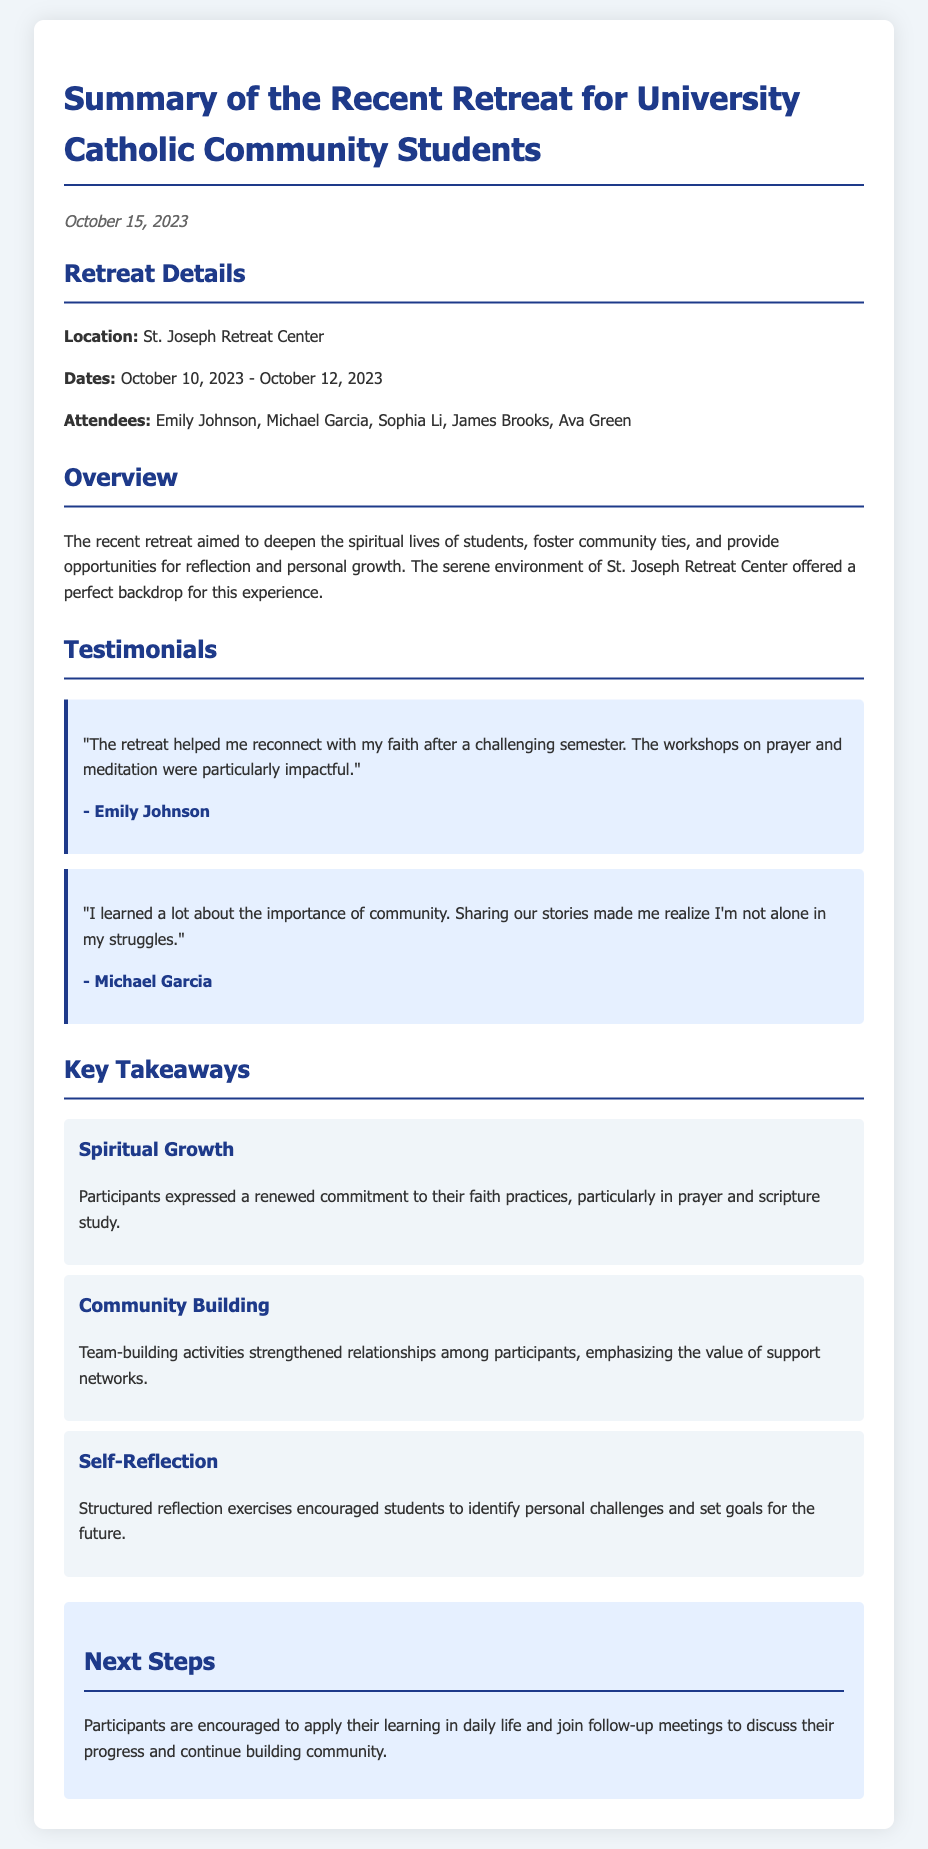What were the retreat dates? The retreat dates are indicated in the document under "Dates" in the "Retreat Details" section.
Answer: October 10, 2023 - October 12, 2023 Who was one of the attendees? The attendees' names are listed in the "Retreat Details" section, and one of them can be used as an answer.
Answer: Emily Johnson What is a key takeaway related to spiritual practices? The key takeaways are mentioned in the "Key Takeaways" section, specifically regarding spiritual growth and practices.
Answer: Spiritual Growth What type of activities emphasized community building? The "Key Takeaways" section refers to types of activities that strengthened relationships, leading to community building.
Answer: Team-building activities What is a next step for participants? The "Next Steps" section outlines what participants are encouraged to do after the retreat, which provides a succinct answer.
Answer: Apply their learning in daily life 